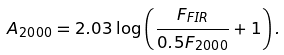Convert formula to latex. <formula><loc_0><loc_0><loc_500><loc_500>A _ { 2 0 0 0 } = 2 . 0 3 \log \left ( \frac { F _ { F I R } } { 0 . 5 F _ { 2 0 0 0 } } + 1 \right ) .</formula> 